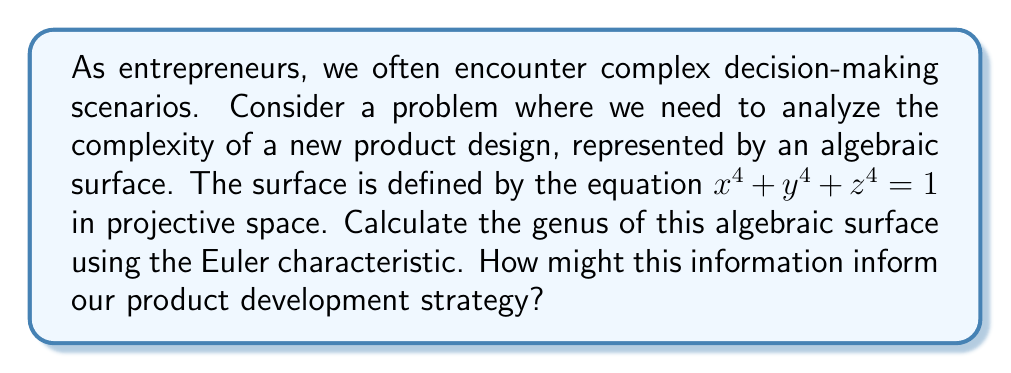Teach me how to tackle this problem. To calculate the genus of the algebraic surface, we'll follow these steps:

1) First, we need to determine the degree of the surface. The equation $x^4 + y^4 + z^4 = 1$ can be homogenized to $x^4 + y^4 + z^4 = w^4$ in projective space. This is a quartic surface, so the degree $d = 4$.

2) For a smooth surface of degree $d$ in projective space, the Euler characteristic $\chi$ is given by the formula:

   $$\chi = (d-1)(d-2)(d-3)/6 + (d-1)(d-2) + 1$$

3) Substituting $d = 4$:

   $$\chi = (4-1)(4-2)(4-3)/6 + (4-1)(4-2) + 1$$
   $$\chi = 3 \cdot 2 \cdot 1 / 6 + 3 \cdot 2 + 1$$
   $$\chi = 1 + 6 + 1 = 8$$

4) For a surface, the genus $g$ is related to the Euler characteristic by:

   $$g = (2 - \chi) / 2$$

5) Substituting our calculated $\chi = 8$:

   $$g = (2 - 8) / 2 = -3$$

Therefore, the genus of the surface is -3.

In terms of product development strategy, a higher absolute value of the genus (whether positive or negative) often indicates a more complex surface. This complexity could represent intricate features or challenging aspects of the product design, potentially impacting manufacturing processes, cost, or user interaction.
Answer: $g = -3$ 